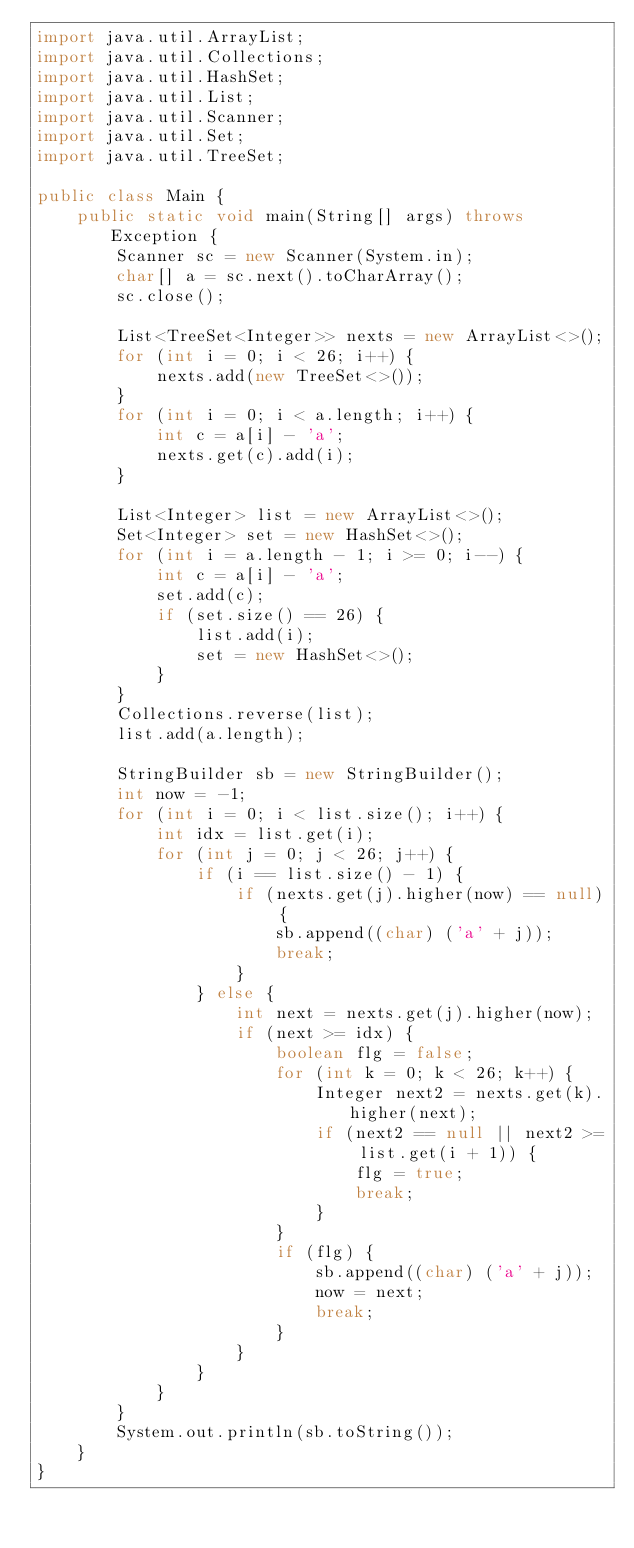Convert code to text. <code><loc_0><loc_0><loc_500><loc_500><_Java_>import java.util.ArrayList;
import java.util.Collections;
import java.util.HashSet;
import java.util.List;
import java.util.Scanner;
import java.util.Set;
import java.util.TreeSet;

public class Main {
	public static void main(String[] args) throws Exception {
		Scanner sc = new Scanner(System.in);
		char[] a = sc.next().toCharArray();
		sc.close();

		List<TreeSet<Integer>> nexts = new ArrayList<>();
		for (int i = 0; i < 26; i++) {
			nexts.add(new TreeSet<>());
		}
		for (int i = 0; i < a.length; i++) {
			int c = a[i] - 'a';
			nexts.get(c).add(i);
		}

		List<Integer> list = new ArrayList<>();
		Set<Integer> set = new HashSet<>();
		for (int i = a.length - 1; i >= 0; i--) {
			int c = a[i] - 'a';
			set.add(c);
			if (set.size() == 26) {
				list.add(i);
				set = new HashSet<>();
			}
		}
		Collections.reverse(list);
		list.add(a.length);

		StringBuilder sb = new StringBuilder();
		int now = -1;
		for (int i = 0; i < list.size(); i++) {
			int idx = list.get(i);
			for (int j = 0; j < 26; j++) {
				if (i == list.size() - 1) {
					if (nexts.get(j).higher(now) == null) {
						sb.append((char) ('a' + j));
						break;
					}
				} else {
					int next = nexts.get(j).higher(now);
					if (next >= idx) {
						boolean flg = false;
						for (int k = 0; k < 26; k++) {
							Integer next2 = nexts.get(k).higher(next);
							if (next2 == null || next2 >= list.get(i + 1)) {
								flg = true;
								break;
							}
						}
						if (flg) {
							sb.append((char) ('a' + j));
							now = next;
							break;
						}
					}
				}
			}
		}
		System.out.println(sb.toString());
	}
}
</code> 